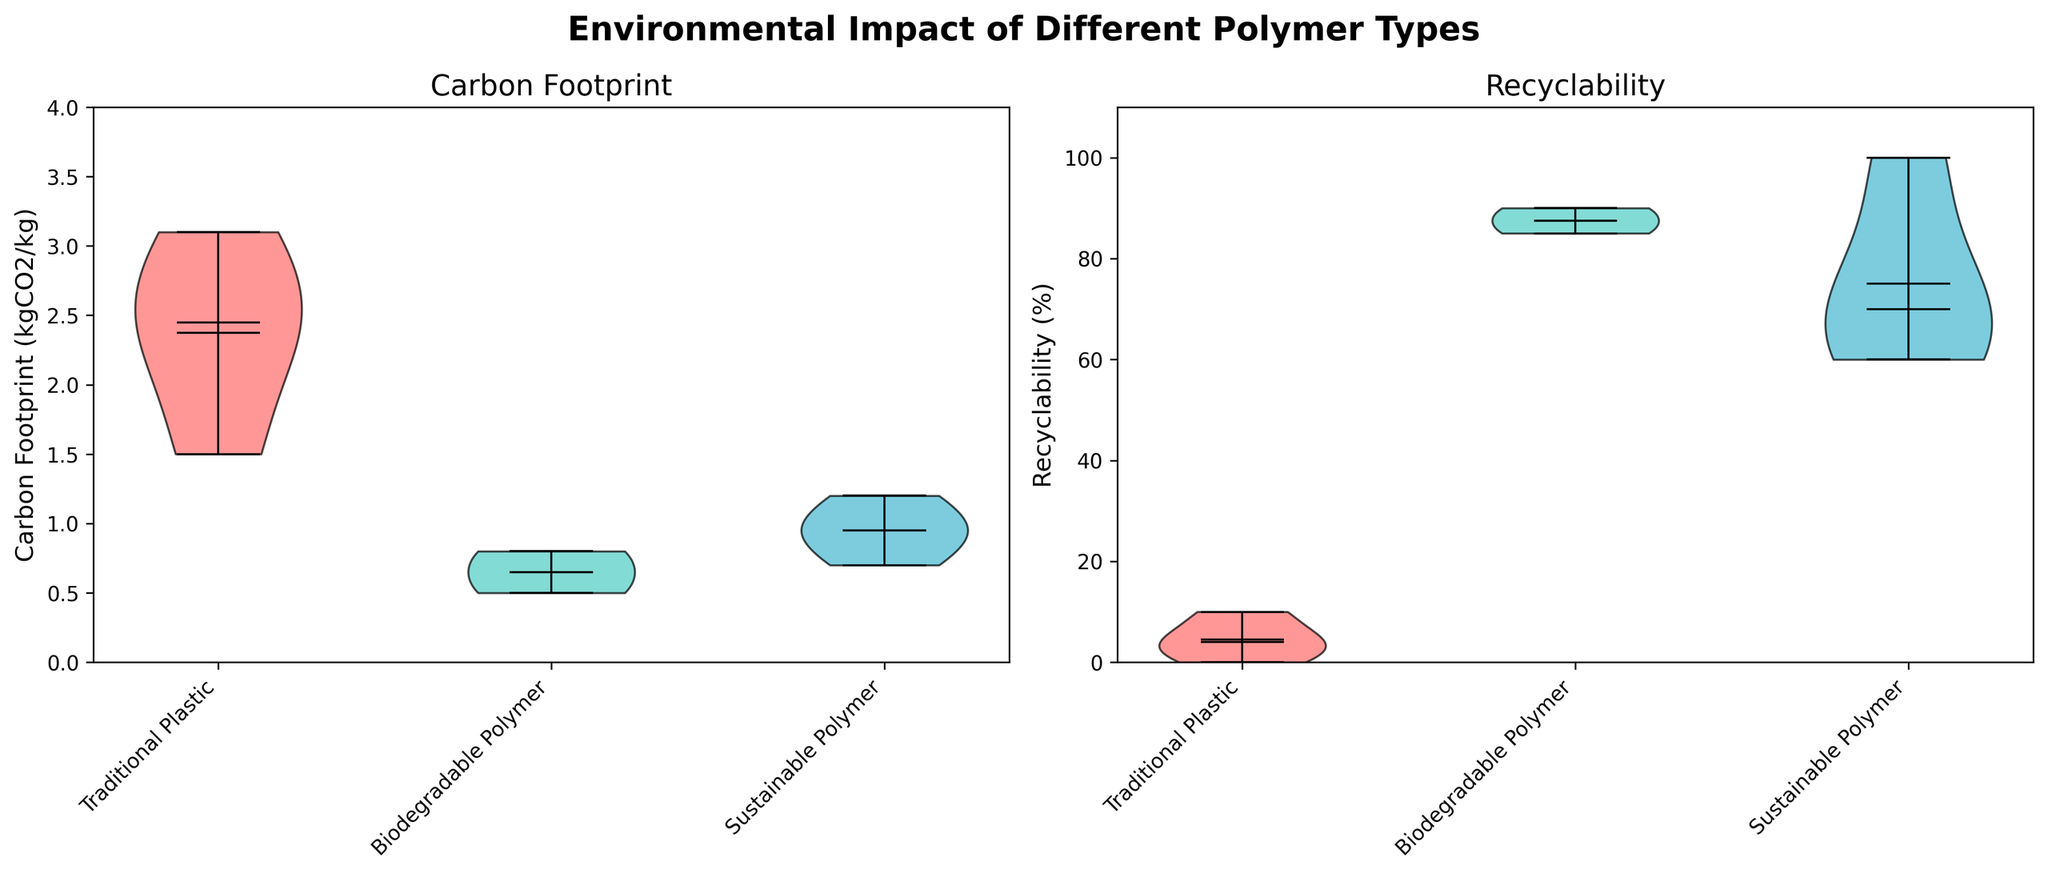What's the title of the figure? The title of the figure is prominently displayed at the top in bold and large font for better visibility. The title is "Environmental Impact of Different Polymer Types".
Answer: Environmental Impact of Different Polymer Types What are the colors representing different polymer types? The colors of the violin plots differentiate the polymer types. The color for Traditional Plastic is red, for Biodegradable Polymer is green, and for Sustainable Polymer is blue.
Answer: Red, Green, Blue Which polymer type has the lowest mean carbon footprint? To determine the polymer type with the lowest mean carbon footprint, observe the white dot (mean indicator) on the carbon footprint violin plot. The lowest mean value is for the Biodegradable Polymer.
Answer: Biodegradable Polymer What are the x-axis labels for both subplots? The x-axis labels for both subplots are based on the categories of polymer types. They are Traditional Plastic, Biodegradable Polymer, and Sustainable Polymer, which are tilted at a 45-degree angle for clarity.
Answer: Traditional Plastic, Biodegradable Polymer, Sustainable Polymer What is the median recyclability percentage for Sustainable Polymer? The recyclability violin plot shows the median as a line inside each violin. For Sustainable Polymer, the median corresponds to the central line, which is around 75%.
Answer: 75% Which polymer type shows the highest range of variability in carbon footprint? The highest range of variability in a violin plot is seen from the spread of the plot. Traditional Plastic has the widest spread in the carbon footprint subplot.
Answer: Traditional Plastic Is there any polymer type with a carbon footprint exceeding 3 kgCO2/kg? To find if any polymer type exceeds 3 kgCO2/kg in carbon footprint, inspect the edges of the violin plots in the carbon footprint subplot. Traditional Plastic has such a high value above 3 kgCO2/kg.
Answer: Yes, Traditional Plastic Compare the mean recyclability percentages of Biodegradable Polymer and Traditional Plastic. The mean recyclability is indicated by the white dot in the recyclability plot. Comparing the positions, Biodegradable Polymer has a much higher mean recyclability than Traditional Plastic.
Answer: Biodegradable Polymer has a higher mean recyclability Which polymer type has the highest recyclability percentage? To find the highest recyclability percentage, look at the topmost part of the violin plot in the recyclability subplot. Sustainable Polymer achieves the maximum recyclability of 100%.
Answer: Sustainable Polymer Are all Sustainable Polymer types more recyclable than all Traditional Plastics? To determine this, compare the lowest recyclability percentage of Sustainable Polymer with the highest of Traditional Plastic in the recyclability plot. Even the lowest recyclability of Sustainable Polymer (60%) is higher than the highest recyclability of Traditional Plastics.
Answer: Yes 